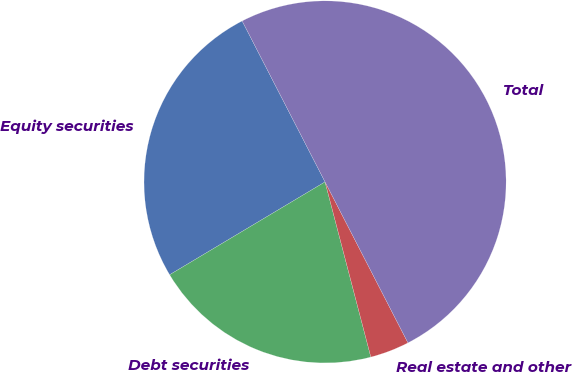<chart> <loc_0><loc_0><loc_500><loc_500><pie_chart><fcel>Equity securities<fcel>Debt securities<fcel>Real estate and other<fcel>Total<nl><fcel>26.0%<fcel>20.5%<fcel>3.5%<fcel>50.0%<nl></chart> 